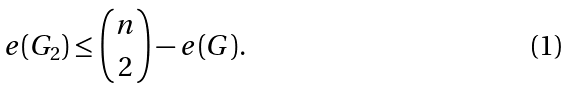Convert formula to latex. <formula><loc_0><loc_0><loc_500><loc_500>e ( G _ { 2 } ) \leq \binom { n } { 2 } - e ( G ) .</formula> 